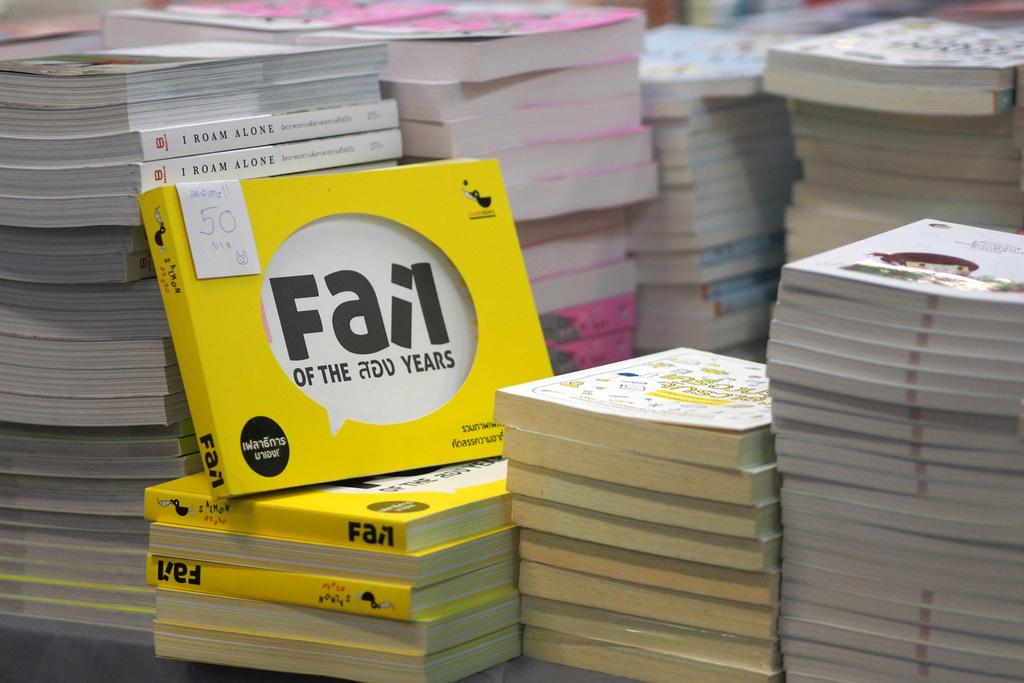Provide a one-sentence caption for the provided image. A stack of books with Fail of the 200 Years featured. 